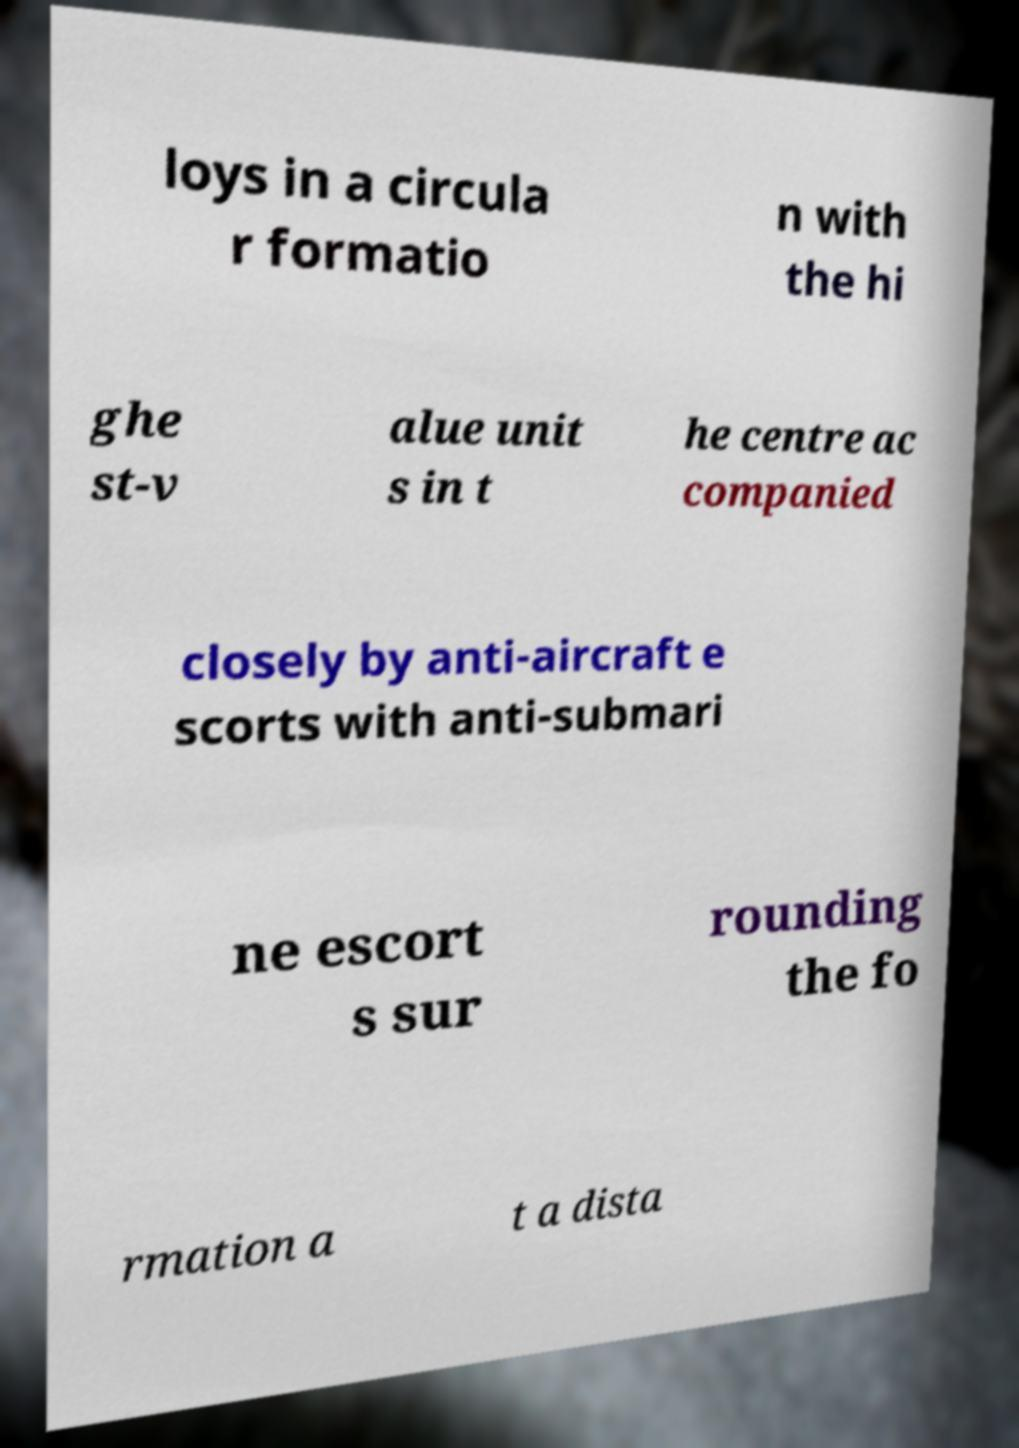Can you read and provide the text displayed in the image?This photo seems to have some interesting text. Can you extract and type it out for me? loys in a circula r formatio n with the hi ghe st-v alue unit s in t he centre ac companied closely by anti-aircraft e scorts with anti-submari ne escort s sur rounding the fo rmation a t a dista 